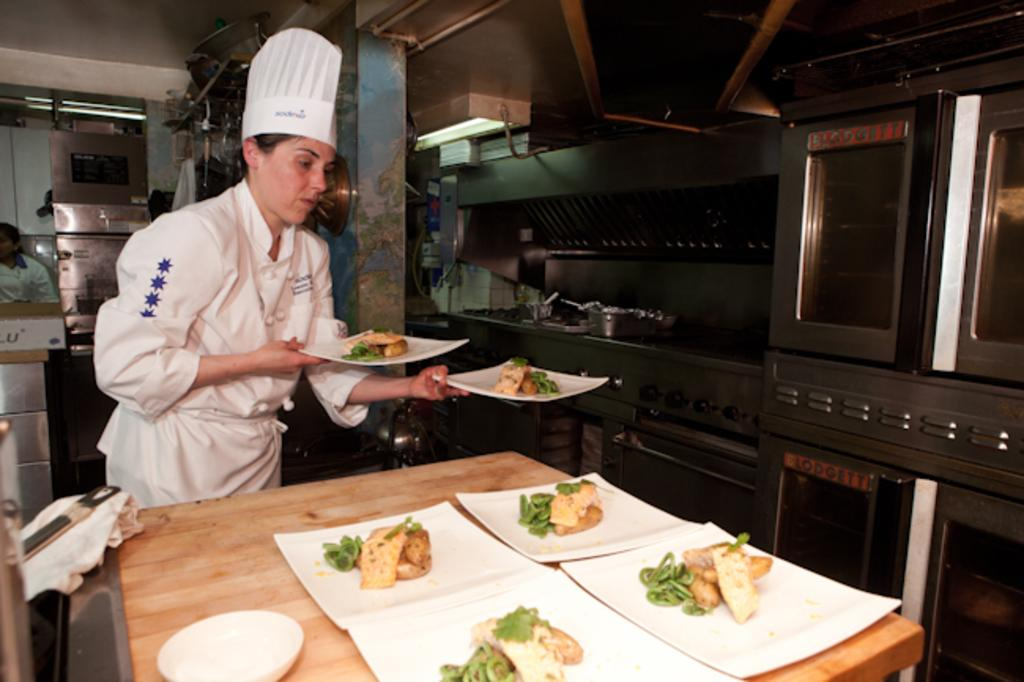Who is present in the image? There is a woman in the image. What is the woman holding in the image? The woman is holding two plates. What can be seen on the table in the image? There are plates, a bowl, and food on the table. What type of appliances are visible in the background? There are stoves and ovens in the background. What else can be seen in the background of the image? There are lights and a wall in the background. What type of advertisement is being displayed on the umbrella in the image? There is no umbrella present in the image, so no advertisement can be observed. Can you describe the bat that is flying around the woman in the image? There is no bat present in the image; the woman is holding plates and standing near a table. 